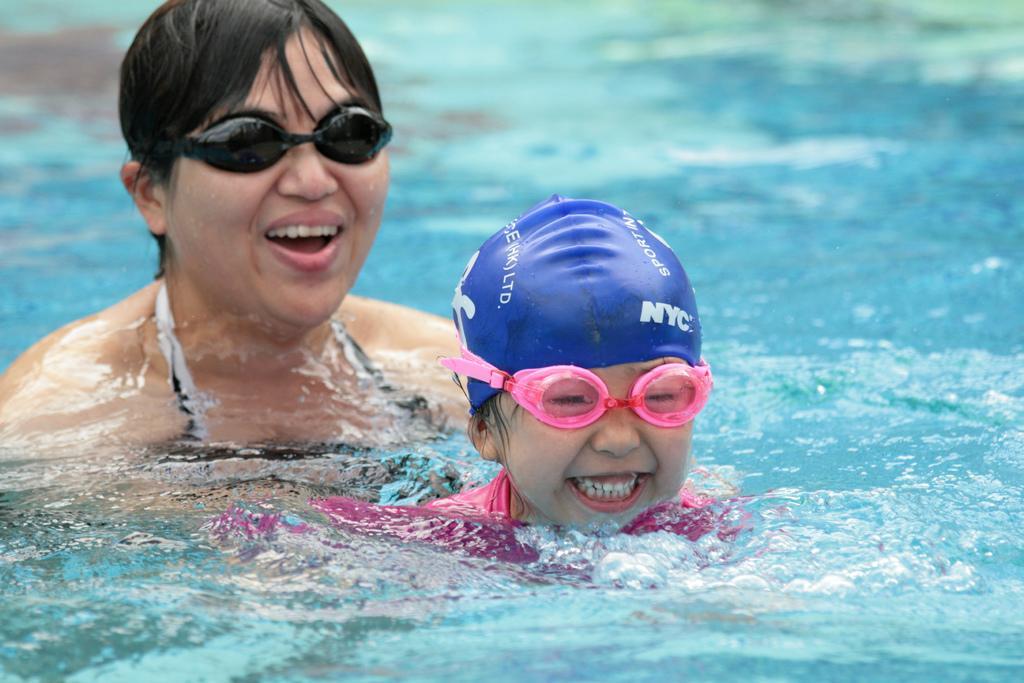In one or two sentences, can you explain what this image depicts? In the center of the image we can see one woman and one kid are in the water. And we can see they are smiling and they are wearing glasses. And we can see they are in different costumes. In the background we can see water. 